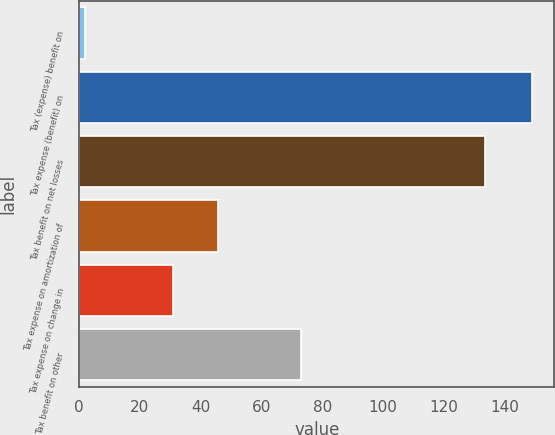Convert chart to OTSL. <chart><loc_0><loc_0><loc_500><loc_500><bar_chart><fcel>Tax (expense) benefit on<fcel>Tax expense (benefit) on<fcel>Tax benefit on net losses<fcel>Tax expense on amortization of<fcel>Tax expense on change in<fcel>Tax benefit on other<nl><fcel>2<fcel>149<fcel>133.7<fcel>45.7<fcel>31<fcel>73<nl></chart> 